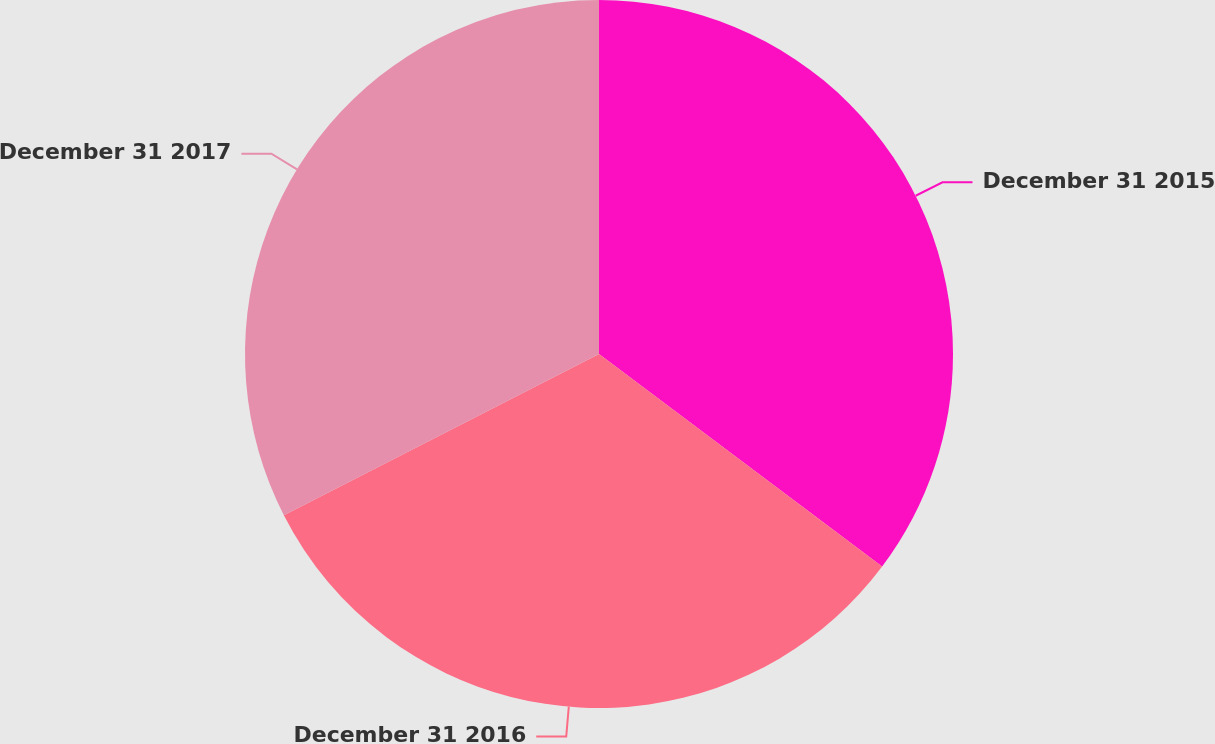Convert chart to OTSL. <chart><loc_0><loc_0><loc_500><loc_500><pie_chart><fcel>December 31 2015<fcel>December 31 2016<fcel>December 31 2017<nl><fcel>35.25%<fcel>32.23%<fcel>32.53%<nl></chart> 